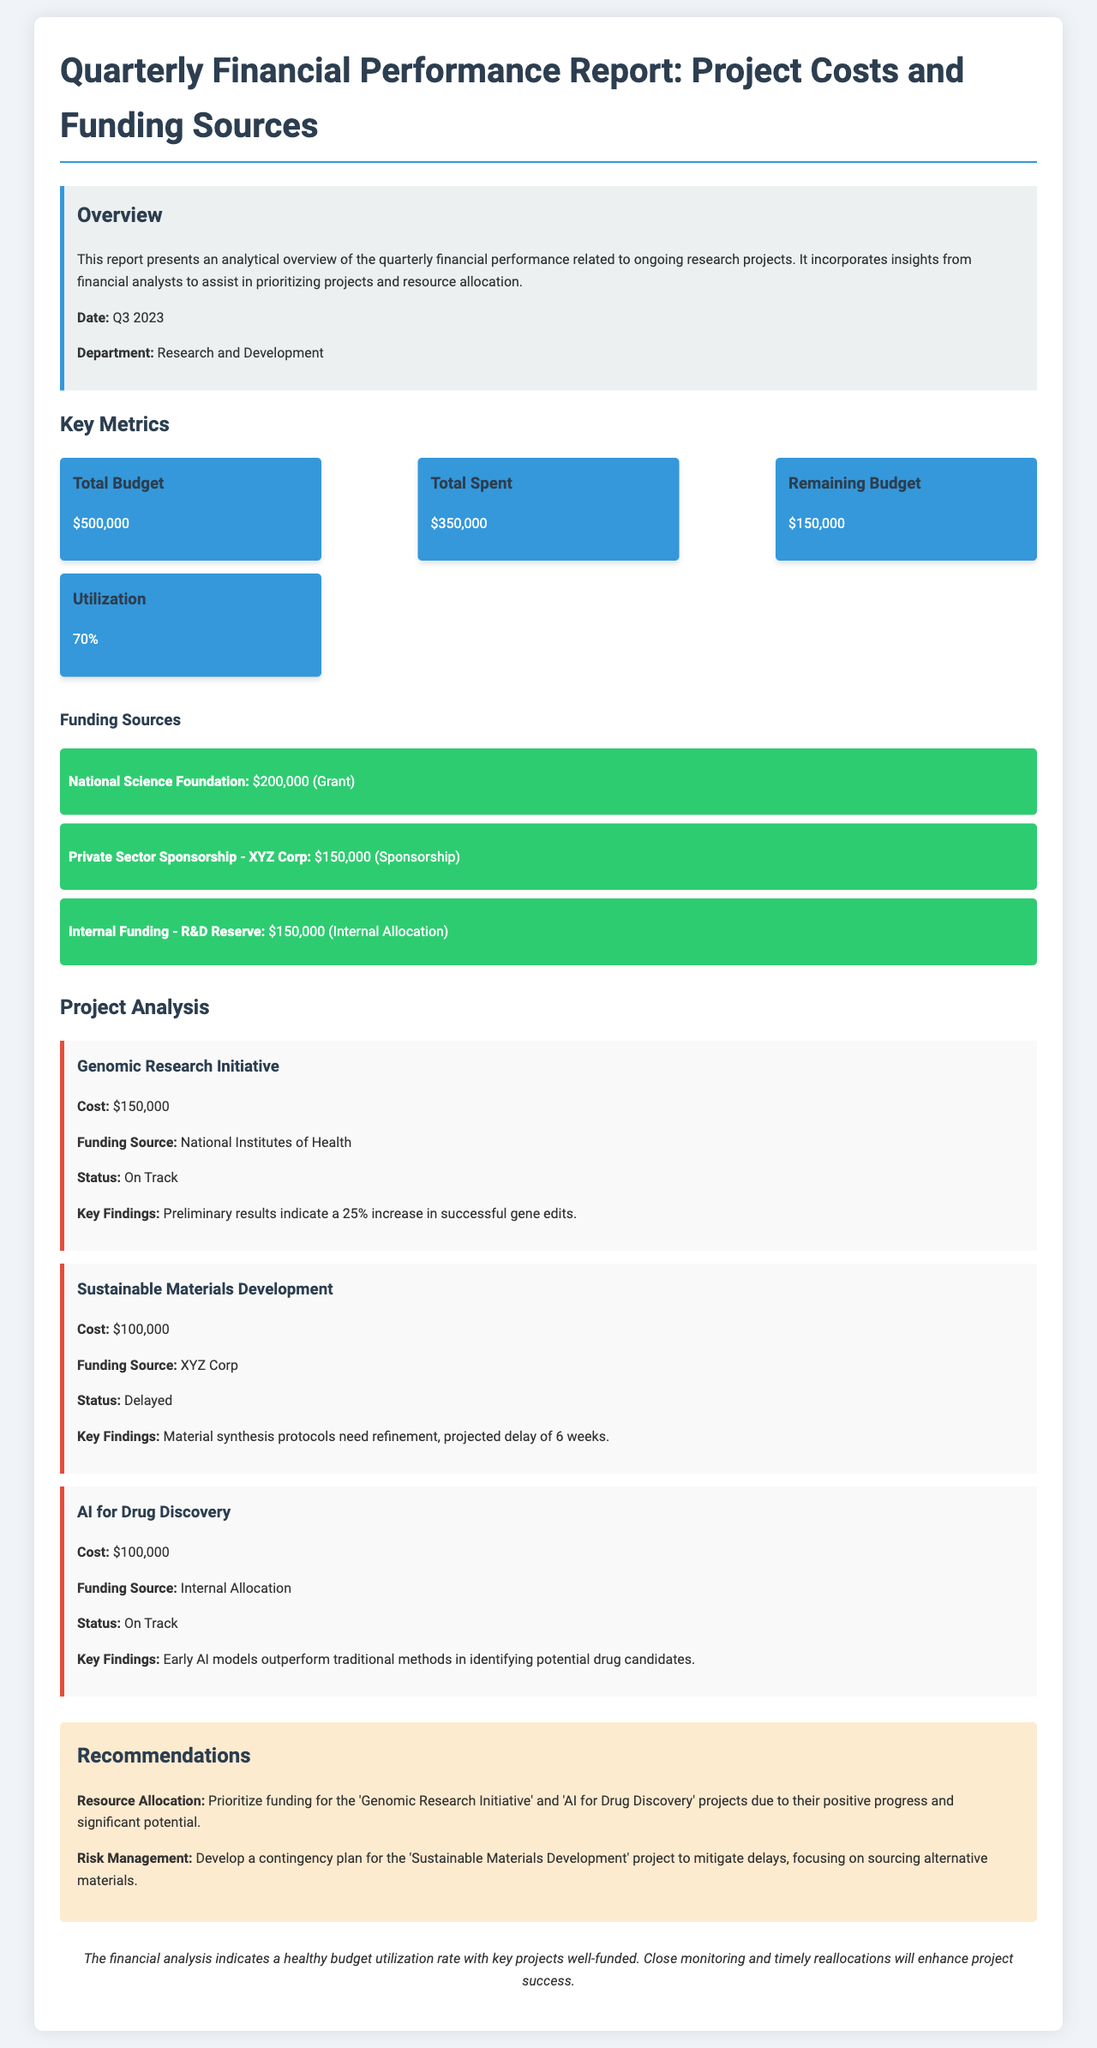What is the total budget? The total budget is explicitly mentioned in the document under Key Metrics.
Answer: $500,000 What is the remaining budget? The remaining budget is calculated by subtracting the total spent from the total budget, which is provided in the document.
Answer: $150,000 What is the utilization percentage? Utilization is directly stated in the Key Metrics section of the report.
Answer: 70% Which funding source contributes the most? The funding sources are listed, and the one with the highest value is the first one mentioned in the document.
Answer: National Science Foundation What is the status of the 'Sustainable Materials Development' project? The status is stated in the project analysis section for the specific project.
Answer: Delayed What key finding is reported for the 'AI for Drug Discovery' project? The key findings section provides insights into the outcomes of this project.
Answer: Early AI models outperform traditional methods in identifying potential drug candidates What recommendation is given for risk management? Recommendations section mentions risk management strategies based on project status.
Answer: Develop a contingency plan for the 'Sustainable Materials Development' project What is the total spent amount? The total spent is listed in the Key Metrics section of the report.
Answer: $350,000 What department is responsible for the report? The department responsible for the report is identified in the Overview section.
Answer: Research and Development 